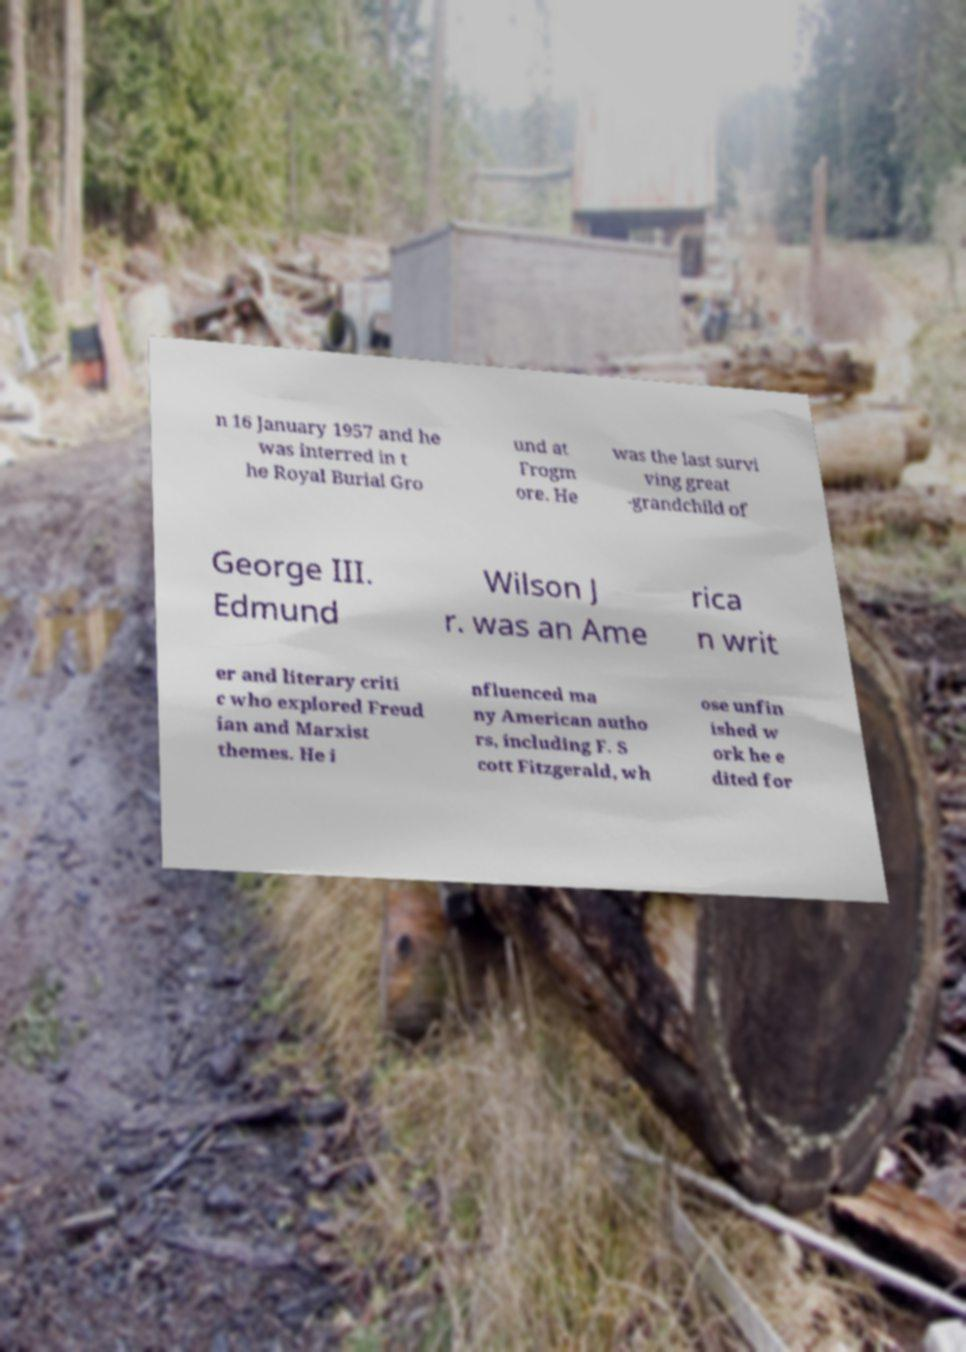Please identify and transcribe the text found in this image. n 16 January 1957 and he was interred in t he Royal Burial Gro und at Frogm ore. He was the last survi ving great -grandchild of George III. Edmund Wilson J r. was an Ame rica n writ er and literary criti c who explored Freud ian and Marxist themes. He i nfluenced ma ny American autho rs, including F. S cott Fitzgerald, wh ose unfin ished w ork he e dited for 